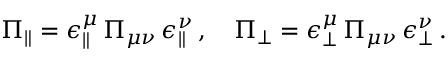<formula> <loc_0><loc_0><loc_500><loc_500>\Pi _ { \| } = \epsilon _ { \| } ^ { \mu } \, \Pi _ { \mu \nu } \, \epsilon _ { \| } ^ { \nu } \, , \quad \Pi _ { \bot } = \epsilon _ { \bot } ^ { \mu } \, \Pi _ { \mu \nu } \, \epsilon _ { \bot } ^ { \nu } \, .</formula> 